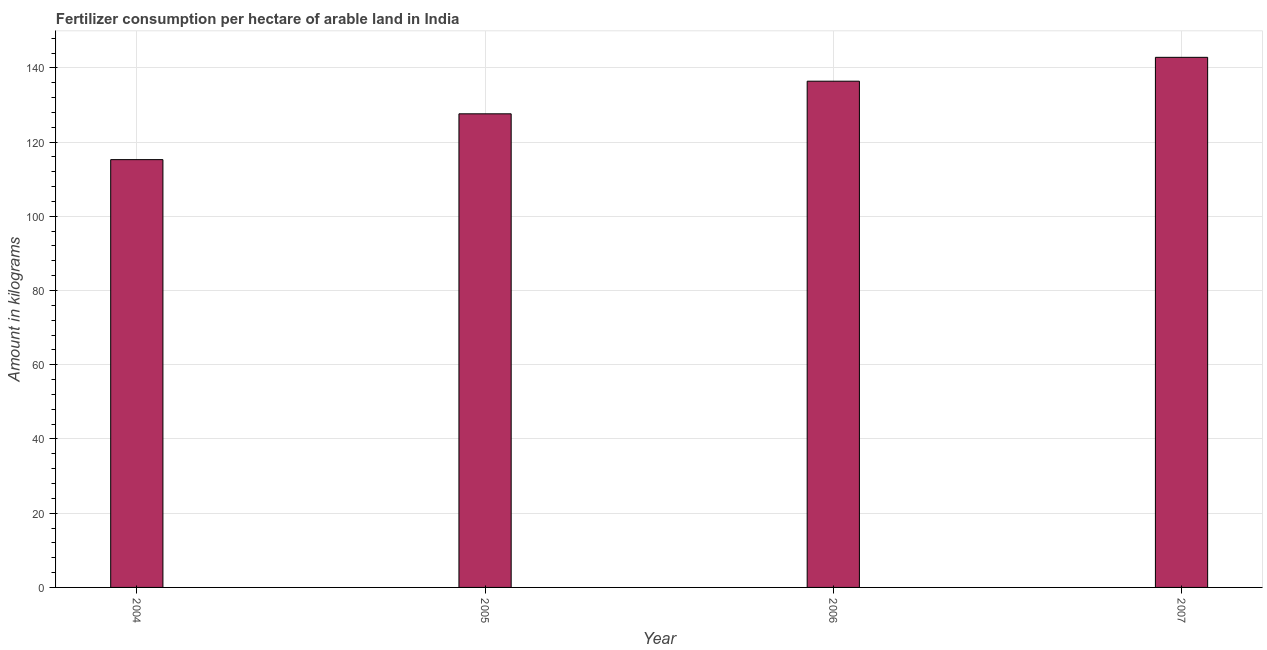Does the graph contain any zero values?
Offer a terse response. No. What is the title of the graph?
Ensure brevity in your answer.  Fertilizer consumption per hectare of arable land in India . What is the label or title of the Y-axis?
Provide a succinct answer. Amount in kilograms. What is the amount of fertilizer consumption in 2004?
Your answer should be very brief. 115.27. Across all years, what is the maximum amount of fertilizer consumption?
Your answer should be compact. 142.84. Across all years, what is the minimum amount of fertilizer consumption?
Make the answer very short. 115.27. In which year was the amount of fertilizer consumption maximum?
Provide a short and direct response. 2007. In which year was the amount of fertilizer consumption minimum?
Keep it short and to the point. 2004. What is the sum of the amount of fertilizer consumption?
Give a very brief answer. 522.13. What is the difference between the amount of fertilizer consumption in 2005 and 2006?
Your response must be concise. -8.79. What is the average amount of fertilizer consumption per year?
Offer a terse response. 130.53. What is the median amount of fertilizer consumption?
Make the answer very short. 132.01. In how many years, is the amount of fertilizer consumption greater than 128 kg?
Keep it short and to the point. 2. What is the ratio of the amount of fertilizer consumption in 2005 to that in 2007?
Offer a very short reply. 0.89. Is the amount of fertilizer consumption in 2005 less than that in 2006?
Your response must be concise. Yes. What is the difference between the highest and the second highest amount of fertilizer consumption?
Provide a succinct answer. 6.43. What is the difference between the highest and the lowest amount of fertilizer consumption?
Make the answer very short. 27.56. Are the values on the major ticks of Y-axis written in scientific E-notation?
Ensure brevity in your answer.  No. What is the Amount in kilograms in 2004?
Keep it short and to the point. 115.27. What is the Amount in kilograms of 2005?
Your answer should be very brief. 127.61. What is the Amount in kilograms of 2006?
Ensure brevity in your answer.  136.4. What is the Amount in kilograms of 2007?
Ensure brevity in your answer.  142.84. What is the difference between the Amount in kilograms in 2004 and 2005?
Your answer should be compact. -12.34. What is the difference between the Amount in kilograms in 2004 and 2006?
Provide a short and direct response. -21.13. What is the difference between the Amount in kilograms in 2004 and 2007?
Provide a succinct answer. -27.56. What is the difference between the Amount in kilograms in 2005 and 2006?
Ensure brevity in your answer.  -8.79. What is the difference between the Amount in kilograms in 2005 and 2007?
Offer a terse response. -15.22. What is the difference between the Amount in kilograms in 2006 and 2007?
Keep it short and to the point. -6.43. What is the ratio of the Amount in kilograms in 2004 to that in 2005?
Give a very brief answer. 0.9. What is the ratio of the Amount in kilograms in 2004 to that in 2006?
Give a very brief answer. 0.84. What is the ratio of the Amount in kilograms in 2004 to that in 2007?
Give a very brief answer. 0.81. What is the ratio of the Amount in kilograms in 2005 to that in 2006?
Your answer should be compact. 0.94. What is the ratio of the Amount in kilograms in 2005 to that in 2007?
Keep it short and to the point. 0.89. What is the ratio of the Amount in kilograms in 2006 to that in 2007?
Your answer should be compact. 0.95. 